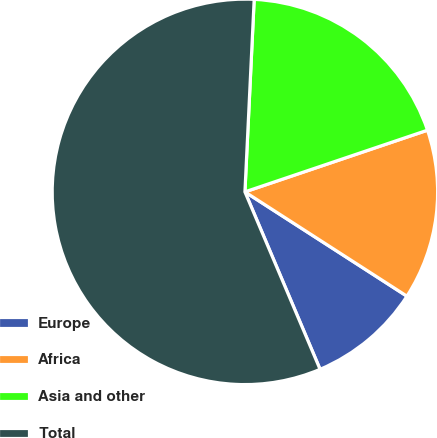Convert chart to OTSL. <chart><loc_0><loc_0><loc_500><loc_500><pie_chart><fcel>Europe<fcel>Africa<fcel>Asia and other<fcel>Total<nl><fcel>9.52%<fcel>14.29%<fcel>19.05%<fcel>57.14%<nl></chart> 